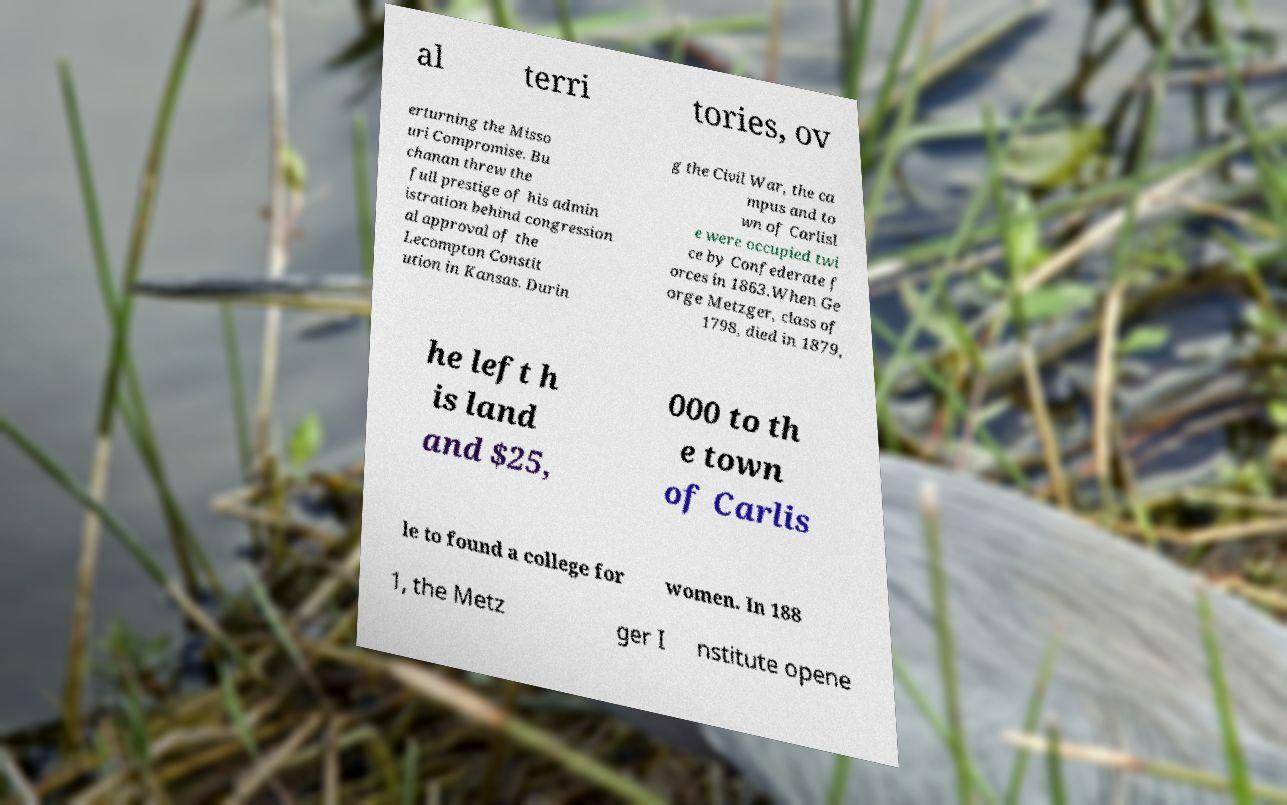Could you extract and type out the text from this image? al terri tories, ov erturning the Misso uri Compromise. Bu chanan threw the full prestige of his admin istration behind congression al approval of the Lecompton Constit ution in Kansas. Durin g the Civil War, the ca mpus and to wn of Carlisl e were occupied twi ce by Confederate f orces in 1863.When Ge orge Metzger, class of 1798, died in 1879, he left h is land and $25, 000 to th e town of Carlis le to found a college for women. In 188 1, the Metz ger I nstitute opene 